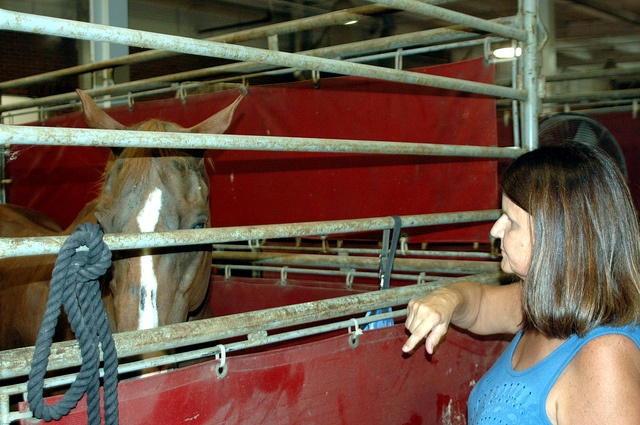Describe the objects in this image and their specific colors. I can see people in darkgreen, gray, black, and tan tones and horse in darkgreen, olive, gray, black, and maroon tones in this image. 